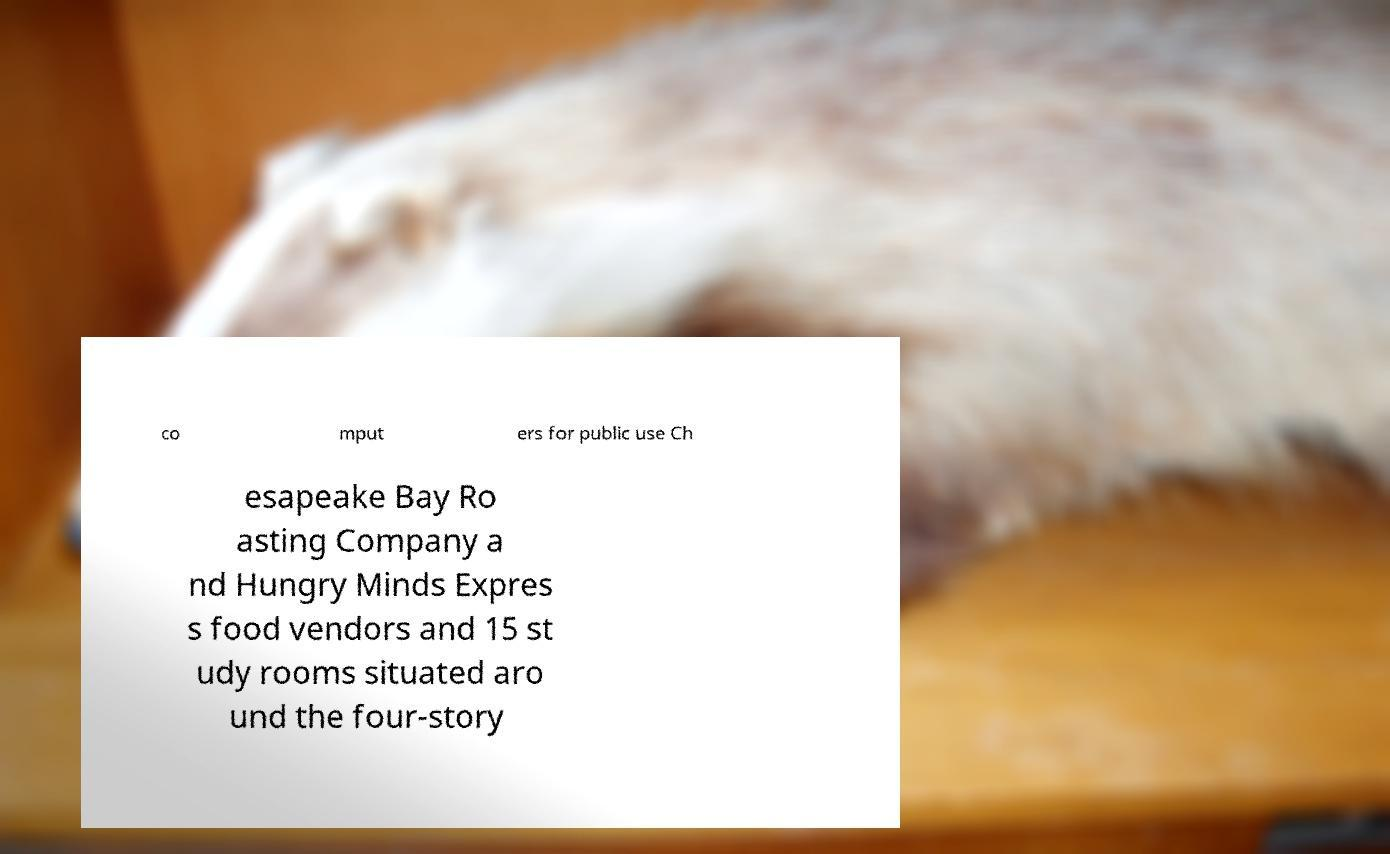Can you accurately transcribe the text from the provided image for me? co mput ers for public use Ch esapeake Bay Ro asting Company a nd Hungry Minds Expres s food vendors and 15 st udy rooms situated aro und the four-story 